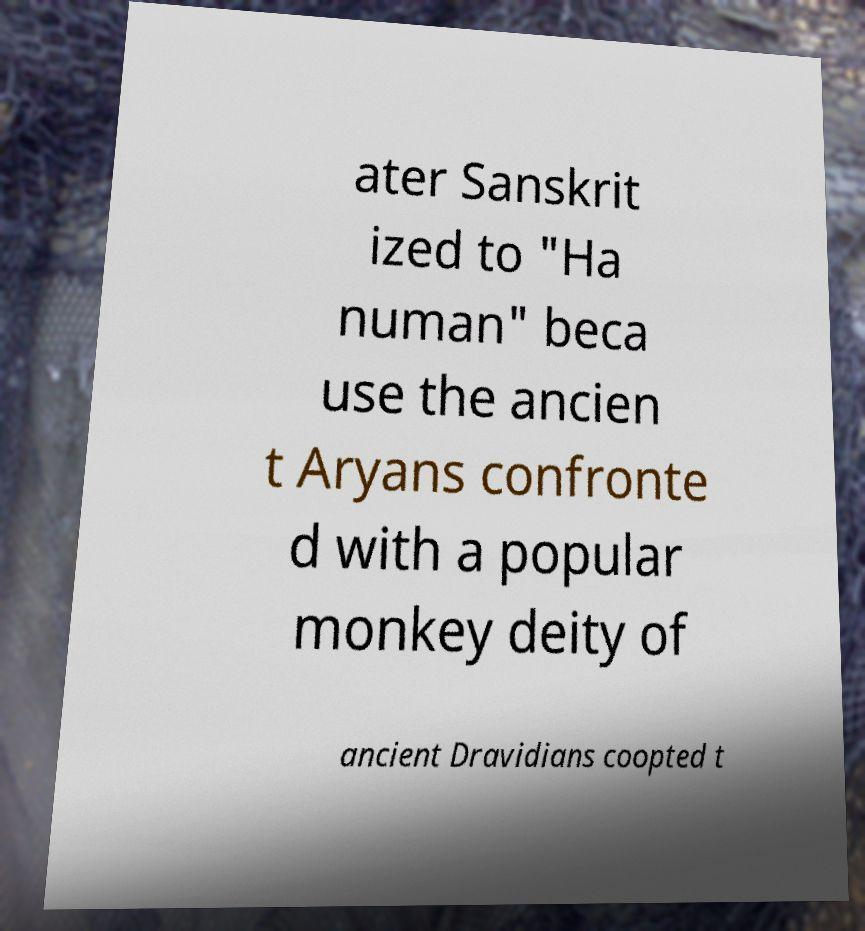What messages or text are displayed in this image? I need them in a readable, typed format. ater Sanskrit ized to "Ha numan" beca use the ancien t Aryans confronte d with a popular monkey deity of ancient Dravidians coopted t 